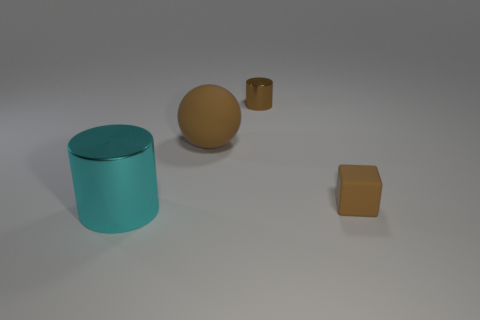Add 3 balls. How many objects exist? 7 Subtract all cyan cylinders. How many cylinders are left? 1 Subtract all spheres. How many objects are left? 3 Add 1 brown matte cubes. How many brown matte cubes exist? 2 Subtract 0 gray blocks. How many objects are left? 4 Subtract all blue spheres. Subtract all green blocks. How many spheres are left? 1 Subtract all metallic cylinders. Subtract all small brown shiny things. How many objects are left? 1 Add 2 brown matte balls. How many brown matte balls are left? 3 